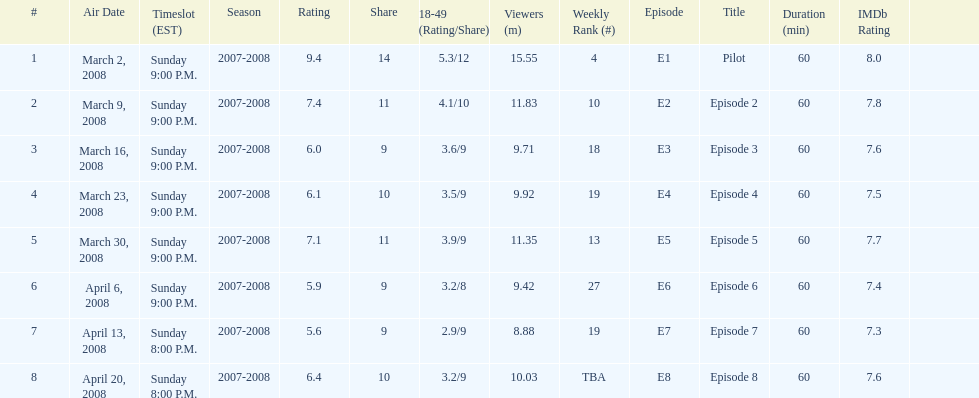Which show had the highest rating? 1. 